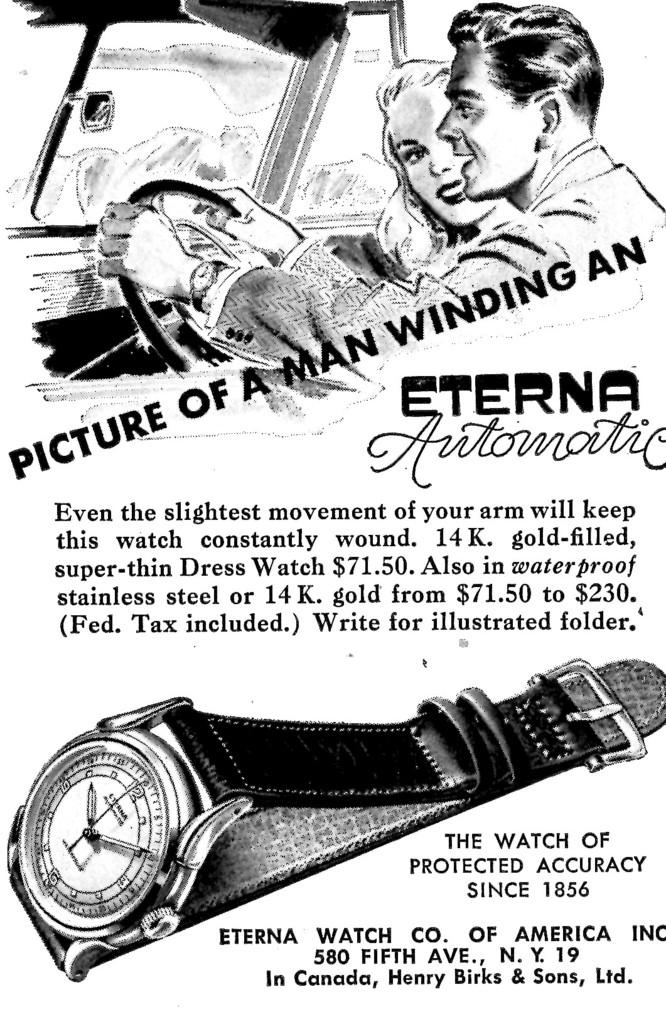<image>
Give a short and clear explanation of the subsequent image. AN OLD ADVERTISMENT PAGE OF A ETERNA AUTOMATIC WATCH 